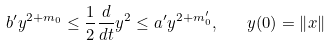<formula> <loc_0><loc_0><loc_500><loc_500>b ^ { \prime } y ^ { 2 + m _ { 0 } } \leq \frac { 1 } { 2 } \frac { d } { d t } y ^ { 2 } \leq a ^ { \prime } y ^ { 2 + m _ { 0 } ^ { \prime } } , \quad y ( 0 ) = \left \| x \right \|</formula> 